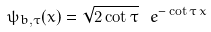Convert formula to latex. <formula><loc_0><loc_0><loc_500><loc_500>\psi _ { b , \tau } ( x ) = \sqrt { 2 \cot \tau } \, \ e ^ { - \cot \tau \, x }</formula> 